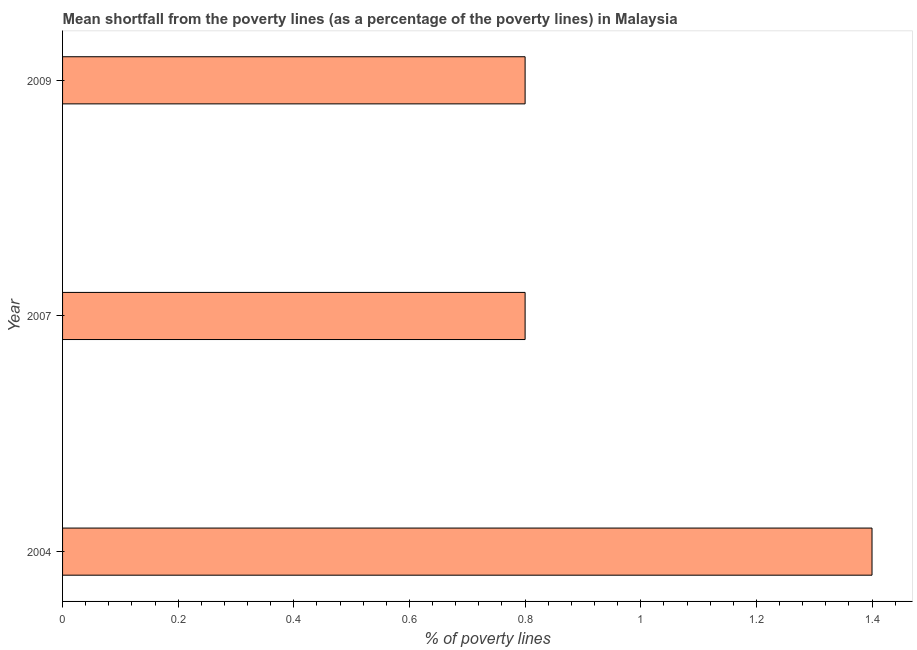Does the graph contain grids?
Your answer should be very brief. No. What is the title of the graph?
Make the answer very short. Mean shortfall from the poverty lines (as a percentage of the poverty lines) in Malaysia. What is the label or title of the X-axis?
Keep it short and to the point. % of poverty lines. What is the poverty gap at national poverty lines in 2009?
Make the answer very short. 0.8. Across all years, what is the minimum poverty gap at national poverty lines?
Offer a very short reply. 0.8. What is the difference between the poverty gap at national poverty lines in 2007 and 2009?
Your response must be concise. 0. In how many years, is the poverty gap at national poverty lines greater than 0.2 %?
Provide a short and direct response. 3. Is the poverty gap at national poverty lines in 2004 less than that in 2007?
Offer a very short reply. No. Is the difference between the poverty gap at national poverty lines in 2004 and 2009 greater than the difference between any two years?
Keep it short and to the point. Yes. What is the difference between two consecutive major ticks on the X-axis?
Your answer should be compact. 0.2. What is the % of poverty lines in 2009?
Offer a terse response. 0.8. What is the difference between the % of poverty lines in 2004 and 2007?
Ensure brevity in your answer.  0.6. What is the ratio of the % of poverty lines in 2004 to that in 2009?
Make the answer very short. 1.75. 